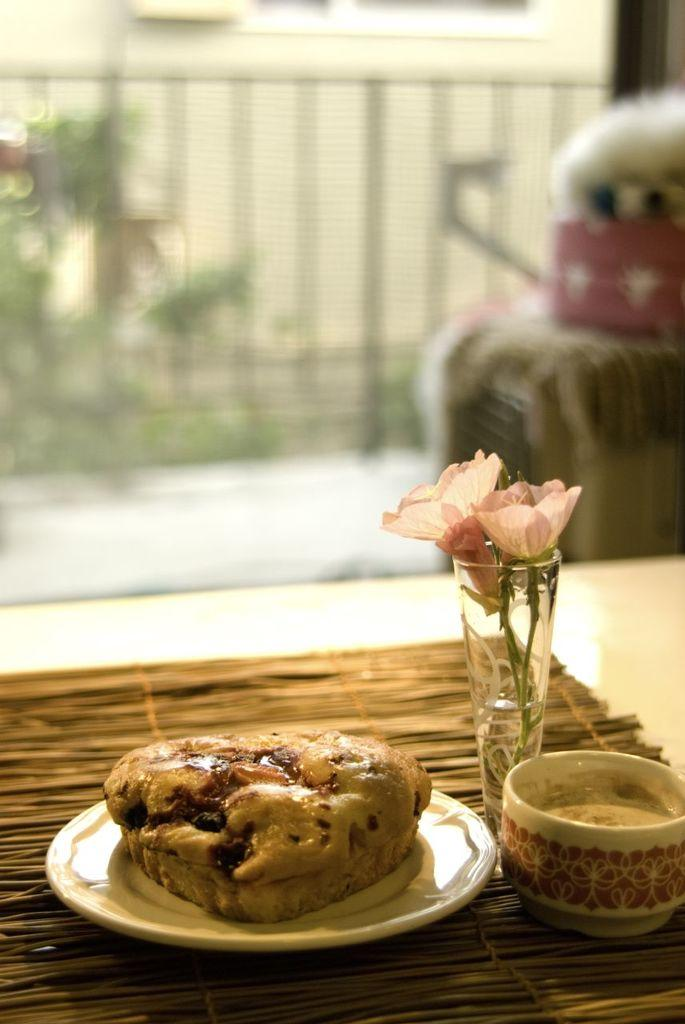What is present on the table in the image? There is a cup with coffee, a vase with a flower, and a plate with food on the table. What type of beverage is in the cup on the table? The cup on the table contains coffee. What can be seen in the background of the image? There is a fence, a dog, and a tree in the background of the image. What might be used to keep the food warm on the table? The image does not show any specific item used to keep the food warm, but an oven could be used for that purpose. How many houses are visible in the image? There are no houses visible in the image; it only shows a table, a cup with coffee, a vase with a flower, a plate with food, a fence, a dog, and a tree in the background. 